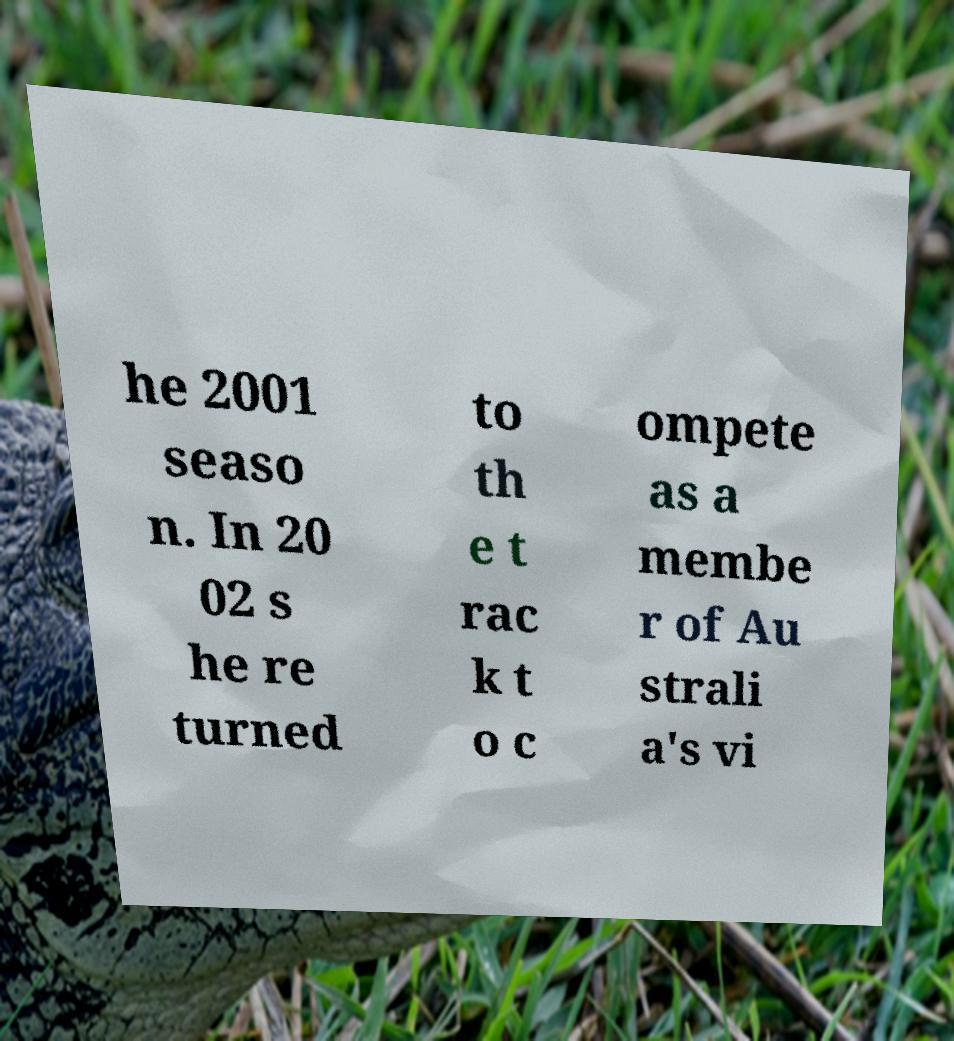There's text embedded in this image that I need extracted. Can you transcribe it verbatim? he 2001 seaso n. In 20 02 s he re turned to th e t rac k t o c ompete as a membe r of Au strali a's vi 